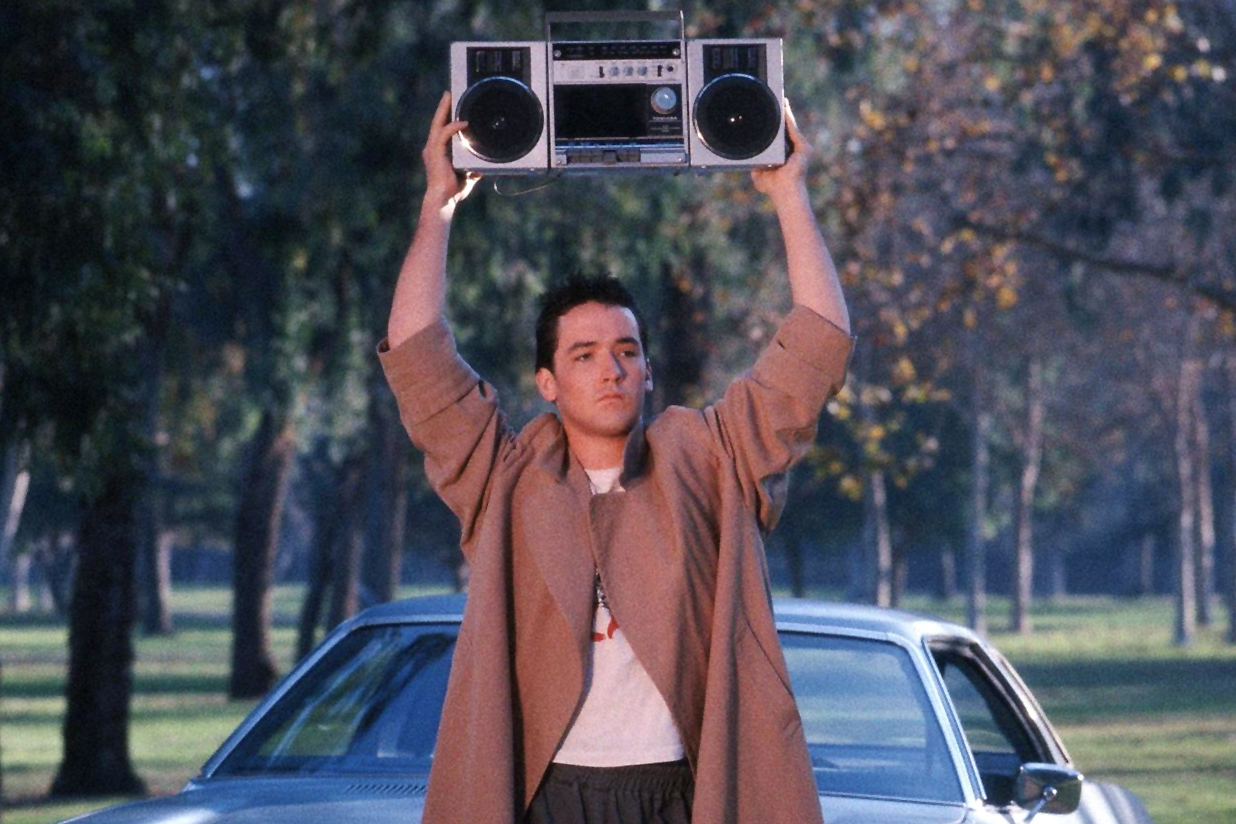Describe the boombox that Lloyd Dobler is holding. The boombox that Lloyd Dobler is holding above his head is a classic 1980s model, featuring a robust black body with silver speakers and various control buttons on the front. Its large, rectangular shape and twin circular speakers give it a commanding presence. The speaker grills and control panel hint at the era's fascination with advanced yet bulky sound equipment. This boombox not only serves as a source of music but also as a powerful symbol of Lloyd's emotions and determination in the context of the film. 